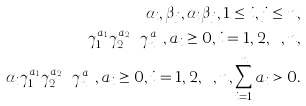Convert formula to latex. <formula><loc_0><loc_0><loc_500><loc_500>\alpha _ { i } , \beta _ { j } , \alpha _ { i } \beta _ { j } , 1 \leq i , j \leq n , \\ \gamma _ { 1 } ^ { a _ { 1 } } \gamma _ { 2 } ^ { a _ { 2 } } \cdots \gamma _ { n } ^ { a _ { n } } , a _ { i } \geq 0 , i = 1 , 2 , \cdots , n , \\ \alpha _ { i } \gamma _ { 1 } ^ { a _ { 1 } } \gamma _ { 2 } ^ { a _ { 2 } } \cdots \gamma _ { n } ^ { a _ { n } } , a _ { i } \geq 0 , i = 1 , 2 , \cdots , n , \sum _ { i = 1 } ^ { n } a _ { i } > 0 .</formula> 